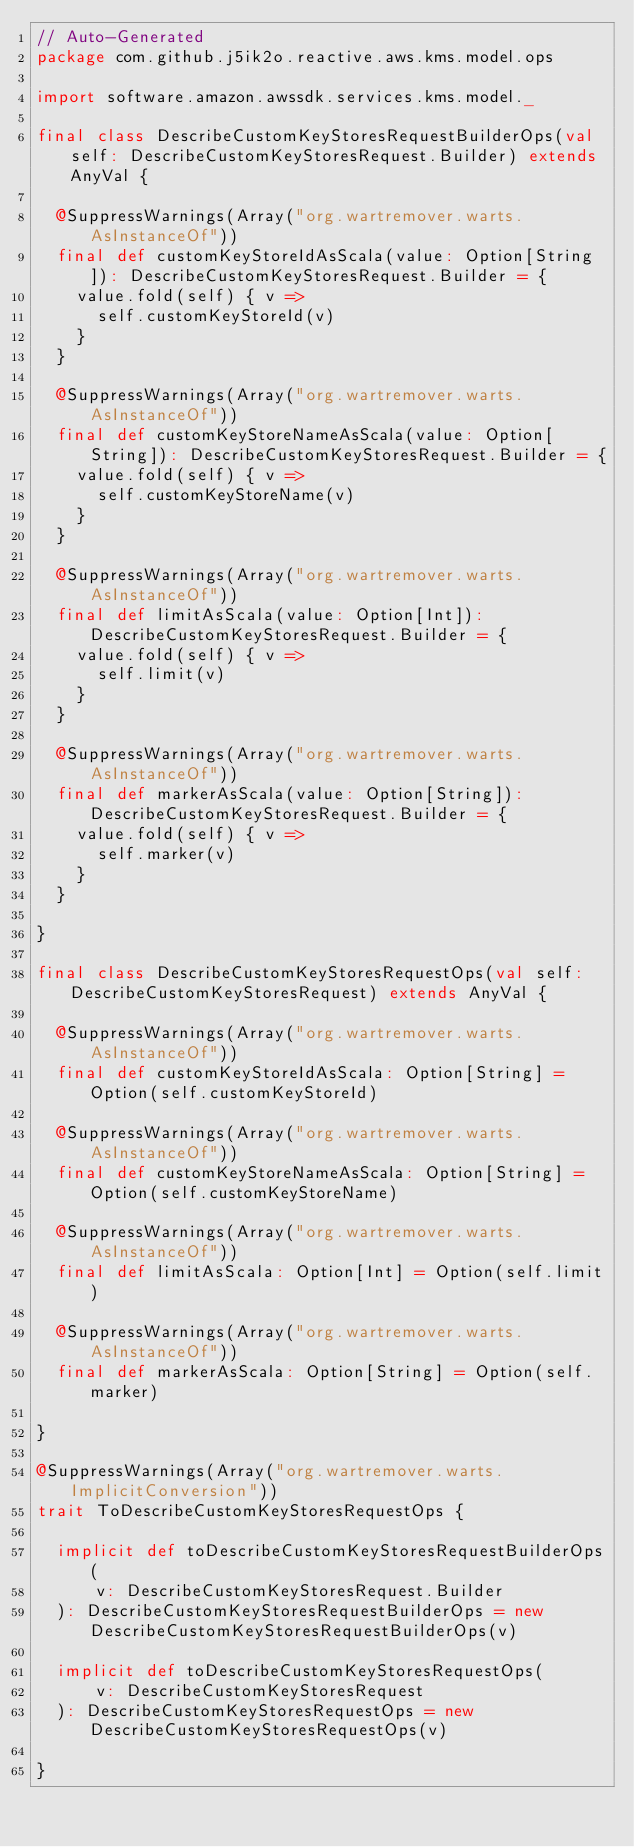<code> <loc_0><loc_0><loc_500><loc_500><_Scala_>// Auto-Generated
package com.github.j5ik2o.reactive.aws.kms.model.ops

import software.amazon.awssdk.services.kms.model._

final class DescribeCustomKeyStoresRequestBuilderOps(val self: DescribeCustomKeyStoresRequest.Builder) extends AnyVal {

  @SuppressWarnings(Array("org.wartremover.warts.AsInstanceOf"))
  final def customKeyStoreIdAsScala(value: Option[String]): DescribeCustomKeyStoresRequest.Builder = {
    value.fold(self) { v =>
      self.customKeyStoreId(v)
    }
  }

  @SuppressWarnings(Array("org.wartremover.warts.AsInstanceOf"))
  final def customKeyStoreNameAsScala(value: Option[String]): DescribeCustomKeyStoresRequest.Builder = {
    value.fold(self) { v =>
      self.customKeyStoreName(v)
    }
  }

  @SuppressWarnings(Array("org.wartremover.warts.AsInstanceOf"))
  final def limitAsScala(value: Option[Int]): DescribeCustomKeyStoresRequest.Builder = {
    value.fold(self) { v =>
      self.limit(v)
    }
  }

  @SuppressWarnings(Array("org.wartremover.warts.AsInstanceOf"))
  final def markerAsScala(value: Option[String]): DescribeCustomKeyStoresRequest.Builder = {
    value.fold(self) { v =>
      self.marker(v)
    }
  }

}

final class DescribeCustomKeyStoresRequestOps(val self: DescribeCustomKeyStoresRequest) extends AnyVal {

  @SuppressWarnings(Array("org.wartremover.warts.AsInstanceOf"))
  final def customKeyStoreIdAsScala: Option[String] = Option(self.customKeyStoreId)

  @SuppressWarnings(Array("org.wartremover.warts.AsInstanceOf"))
  final def customKeyStoreNameAsScala: Option[String] = Option(self.customKeyStoreName)

  @SuppressWarnings(Array("org.wartremover.warts.AsInstanceOf"))
  final def limitAsScala: Option[Int] = Option(self.limit)

  @SuppressWarnings(Array("org.wartremover.warts.AsInstanceOf"))
  final def markerAsScala: Option[String] = Option(self.marker)

}

@SuppressWarnings(Array("org.wartremover.warts.ImplicitConversion"))
trait ToDescribeCustomKeyStoresRequestOps {

  implicit def toDescribeCustomKeyStoresRequestBuilderOps(
      v: DescribeCustomKeyStoresRequest.Builder
  ): DescribeCustomKeyStoresRequestBuilderOps = new DescribeCustomKeyStoresRequestBuilderOps(v)

  implicit def toDescribeCustomKeyStoresRequestOps(
      v: DescribeCustomKeyStoresRequest
  ): DescribeCustomKeyStoresRequestOps = new DescribeCustomKeyStoresRequestOps(v)

}
</code> 